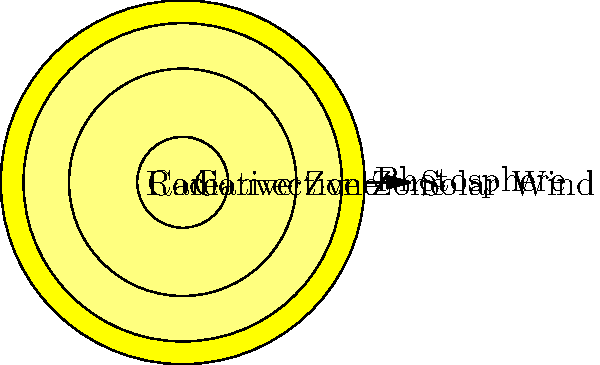In the cross-sectional diagram of the Sun, which layer is responsible for transporting energy primarily through the movement of hot plasma, much like the circulation of voters in a local election? To answer this question, let's examine the layers of the Sun from the inside out:

1. Core: This is the central region where nuclear fusion occurs, generating the Sun's energy. It's like the heart of a community where important decisions are made.

2. Radiative Zone: In this layer, energy is transported outward through radiation. This is similar to how information might be disseminated through official channels in a local government.

3. Convective Zone: This is the layer we're looking for. Here, energy is transported through the physical movement of hot plasma rising and cooler plasma sinking. This process is called convection.

4. Photosphere: This is the visible surface of the Sun, where the energy finally escapes into space.

The convective zone is most like the circulation of voters in a local election because:

a) It involves the physical movement of material (plasma in the Sun, people in an election).
b) It's a dynamic process, with constant circulation (regular election cycles).
c) It's crucial for transferring energy/information from the interior to the surface (from voters to elected officials).

Just as the convective zone is essential for the Sun's energy transport, active voter participation is vital for a healthy local democracy.
Answer: Convective Zone 